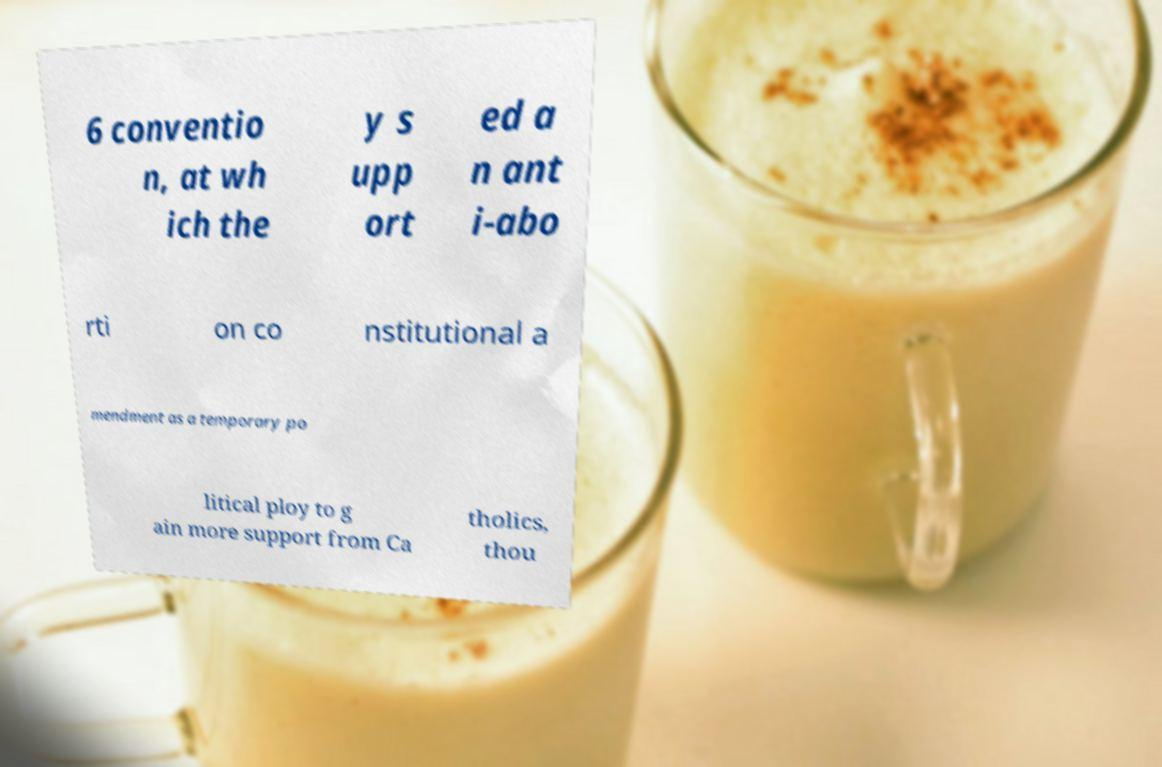Can you read and provide the text displayed in the image?This photo seems to have some interesting text. Can you extract and type it out for me? 6 conventio n, at wh ich the y s upp ort ed a n ant i-abo rti on co nstitutional a mendment as a temporary po litical ploy to g ain more support from Ca tholics, thou 